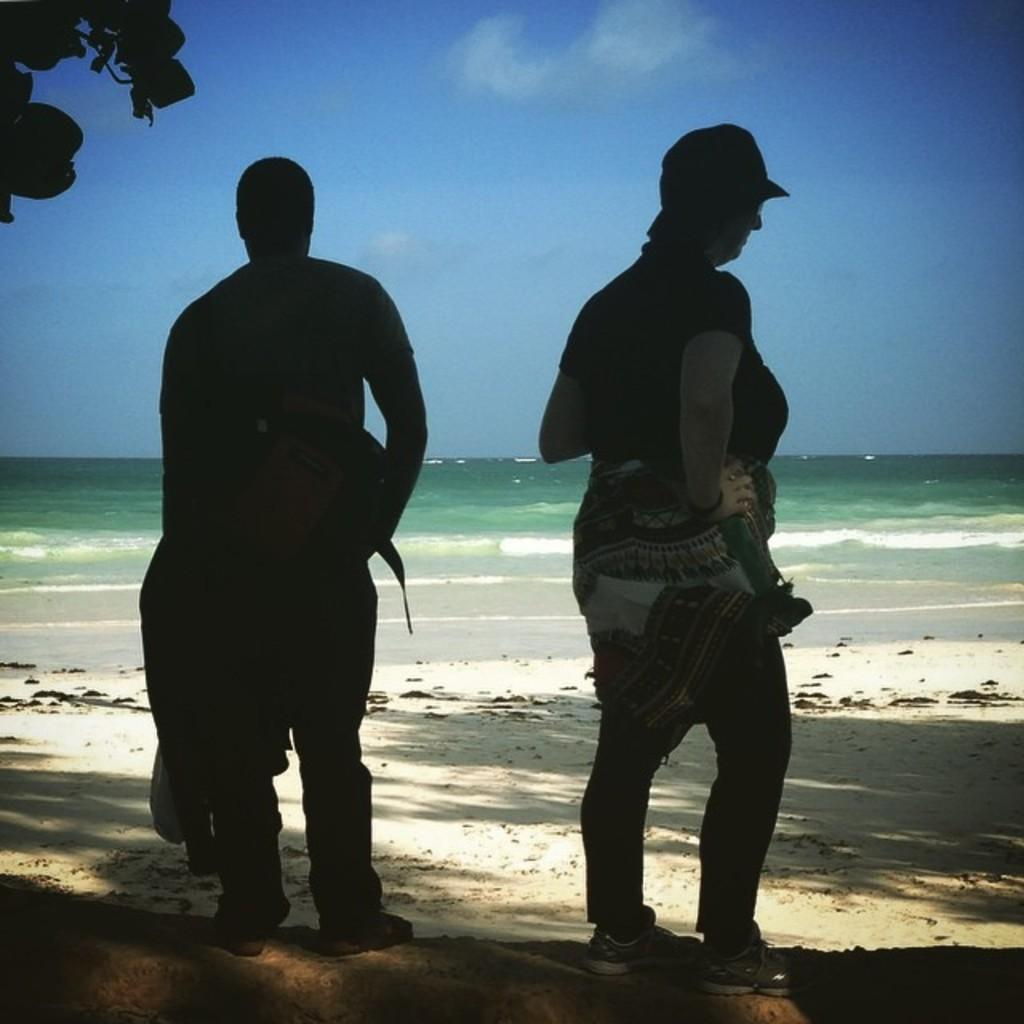How many people are in the image? There are two people in the image. Where are the people located in the image? The people are standing near a seashore. What is the main feature of the landscape in the image? There is a large water body in the image. What type of vegetation can be seen in the image? There are leaves of a tree in the image. What is the condition of the sky in the image? The sky is visible in the image and appears cloudy. Can you see the man adjusting the moon in the image? There is no man adjusting the moon in the image; the image features two people standing near a seashore with a cloudy sky. 